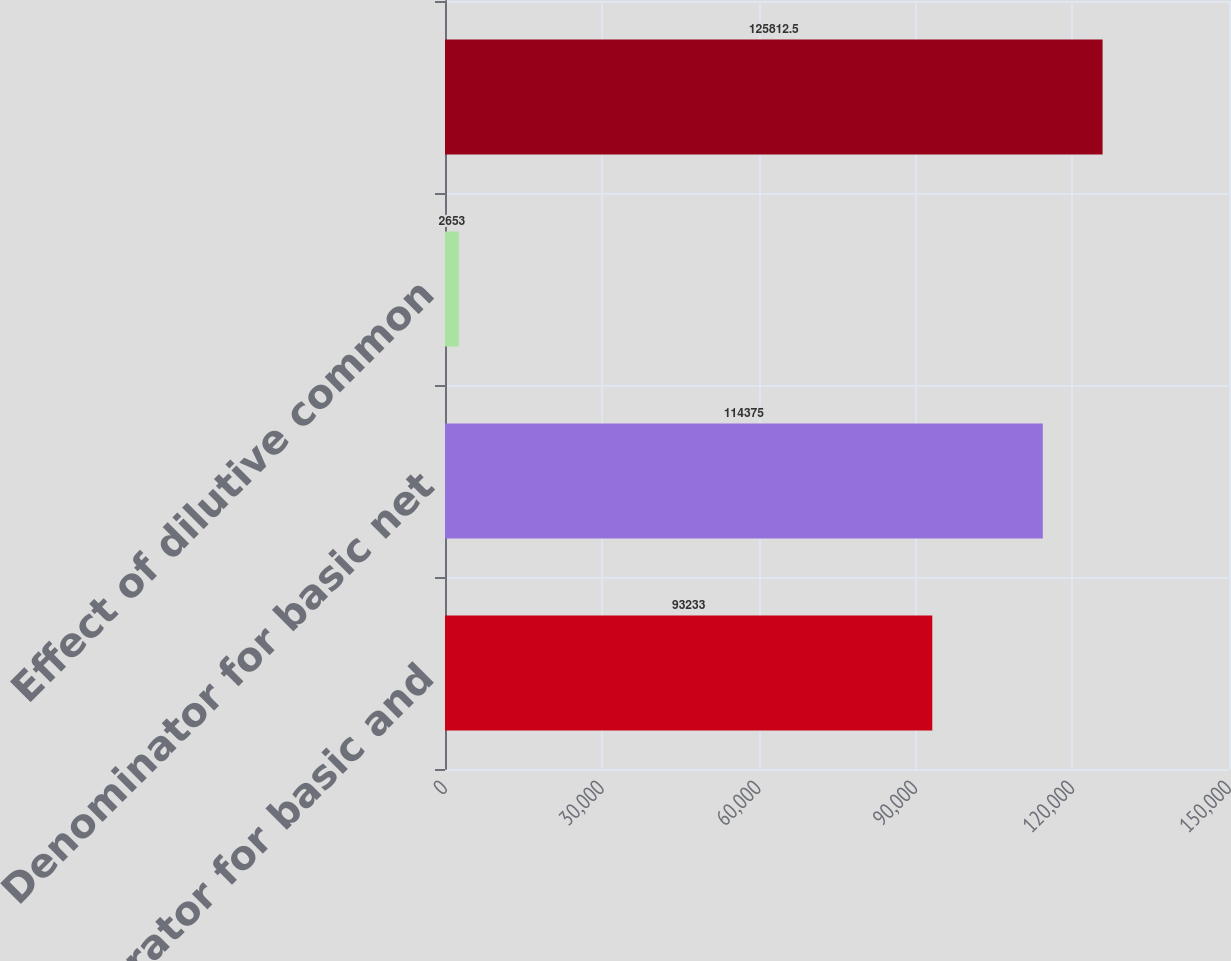Convert chart to OTSL. <chart><loc_0><loc_0><loc_500><loc_500><bar_chart><fcel>Numerator for basic and<fcel>Denominator for basic net<fcel>Effect of dilutive common<fcel>Unnamed: 3<nl><fcel>93233<fcel>114375<fcel>2653<fcel>125812<nl></chart> 